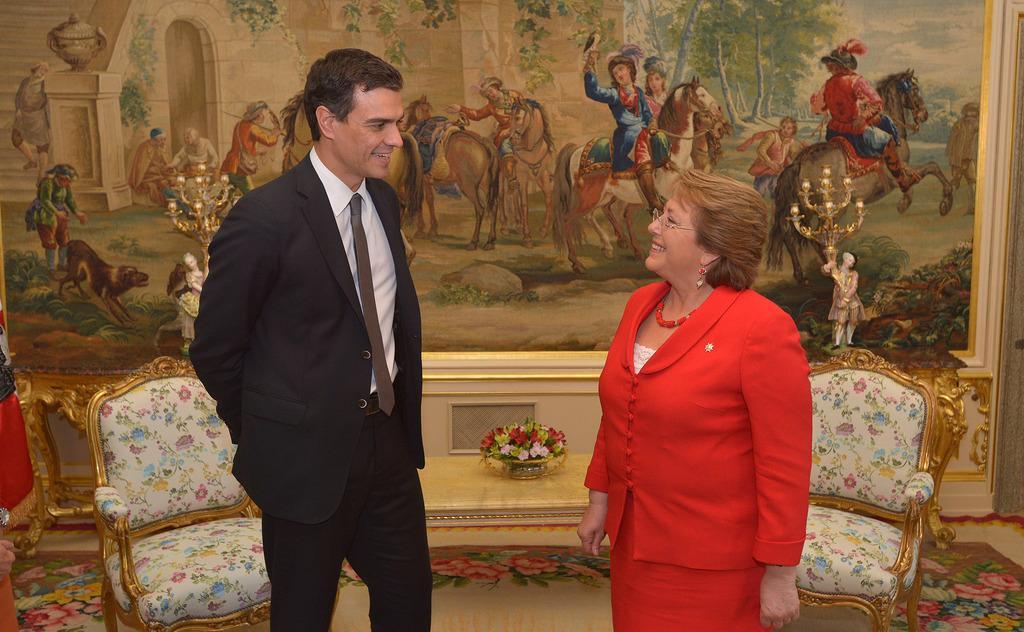Describe this image in one or two sentences. In this picture I can see there are two persons standing here and and one of them is a woman and she is red color shirt and the man is wearing a black blazer. In the backdrop there is a photo graph and there are two chairs in the backdrop. 